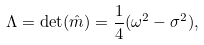<formula> <loc_0><loc_0><loc_500><loc_500>\Lambda = \det ( \hat { m } ) = \frac { 1 } { 4 } ( \omega ^ { 2 } - \sigma ^ { 2 } ) ,</formula> 